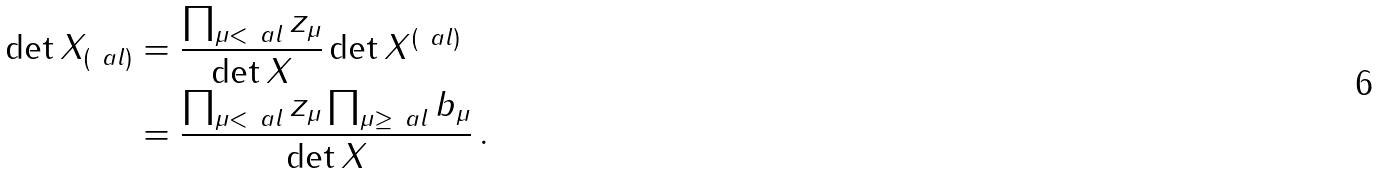<formula> <loc_0><loc_0><loc_500><loc_500>\det X _ { ( \ a l ) } & = \frac { \prod _ { \mu < \ a l } z _ { \mu } } { \det X } \det X ^ { ( \ a l ) } \\ & = \frac { \prod _ { \mu < \ a l } z _ { \mu } \prod _ { \mu \geq \ a l } b _ { \mu } } { \det X } \, .</formula> 